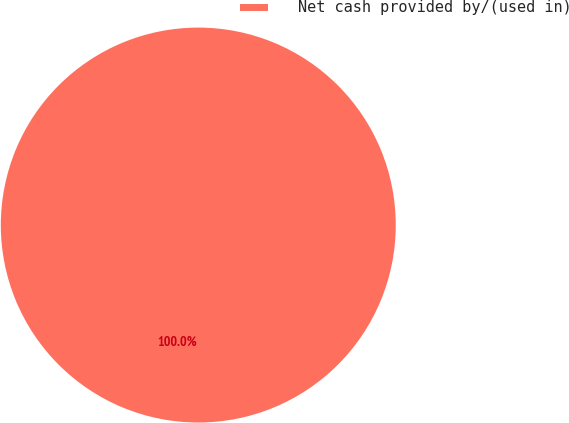<chart> <loc_0><loc_0><loc_500><loc_500><pie_chart><fcel>Net cash provided by/(used in)<nl><fcel>100.0%<nl></chart> 